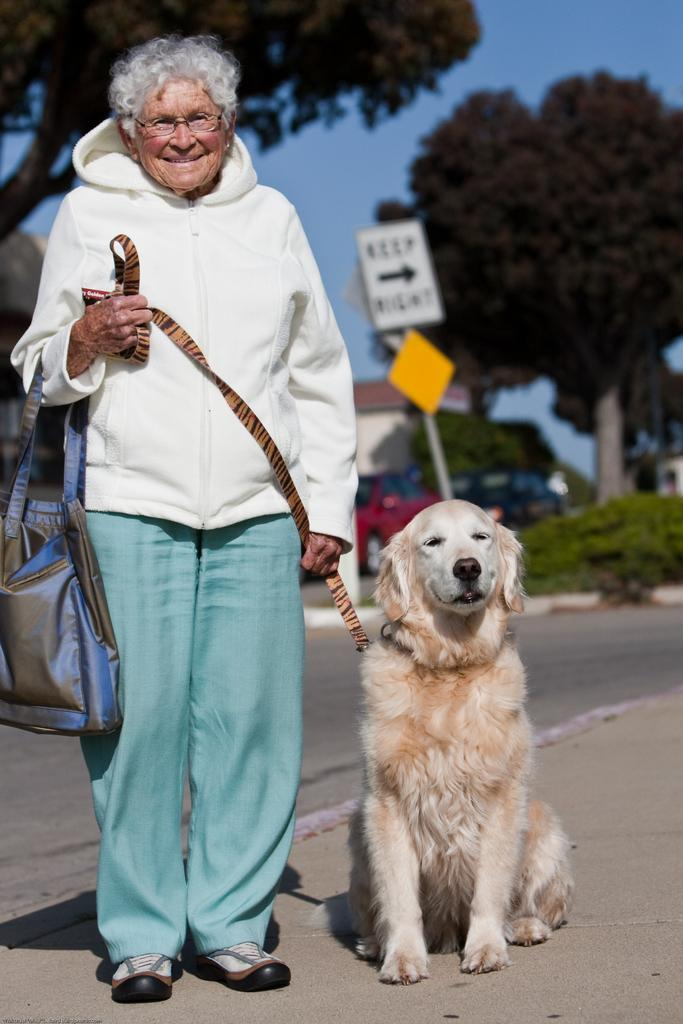Who is the main subject in the image? There is an old woman in the image. What is the old woman holding in her hand? The old woman is holding a dog's belt and a bag. What can be seen in the background of the image? There are sign boards, trees, and buildings in the background of the image. What type of engine is visible in the image? There is no engine present in the image. What is the tendency of the old woman in the image? The image does not provide information about the old woman's tendencies or habits. 